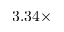<formula> <loc_0><loc_0><loc_500><loc_500>3 . 3 4 \times</formula> 